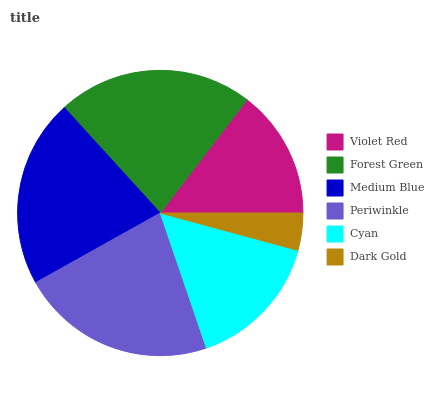Is Dark Gold the minimum?
Answer yes or no. Yes. Is Forest Green the maximum?
Answer yes or no. Yes. Is Medium Blue the minimum?
Answer yes or no. No. Is Medium Blue the maximum?
Answer yes or no. No. Is Forest Green greater than Medium Blue?
Answer yes or no. Yes. Is Medium Blue less than Forest Green?
Answer yes or no. Yes. Is Medium Blue greater than Forest Green?
Answer yes or no. No. Is Forest Green less than Medium Blue?
Answer yes or no. No. Is Medium Blue the high median?
Answer yes or no. Yes. Is Cyan the low median?
Answer yes or no. Yes. Is Periwinkle the high median?
Answer yes or no. No. Is Periwinkle the low median?
Answer yes or no. No. 